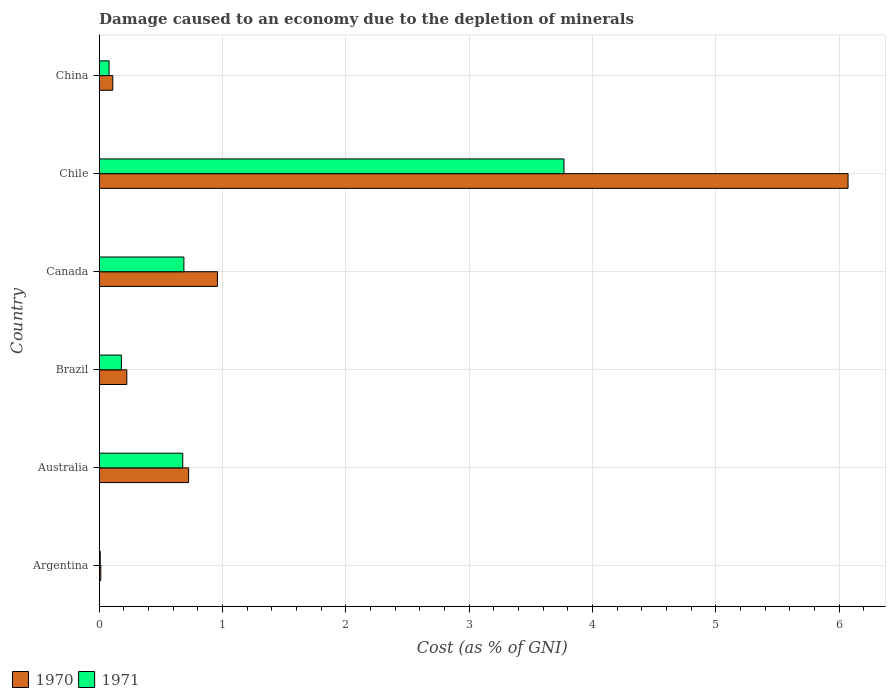How many groups of bars are there?
Provide a succinct answer. 6. Are the number of bars per tick equal to the number of legend labels?
Provide a succinct answer. Yes. Are the number of bars on each tick of the Y-axis equal?
Provide a short and direct response. Yes. What is the cost of damage caused due to the depletion of minerals in 1971 in Australia?
Your answer should be very brief. 0.68. Across all countries, what is the maximum cost of damage caused due to the depletion of minerals in 1971?
Give a very brief answer. 3.77. Across all countries, what is the minimum cost of damage caused due to the depletion of minerals in 1970?
Provide a short and direct response. 0.01. In which country was the cost of damage caused due to the depletion of minerals in 1971 maximum?
Give a very brief answer. Chile. What is the total cost of damage caused due to the depletion of minerals in 1971 in the graph?
Provide a short and direct response. 5.4. What is the difference between the cost of damage caused due to the depletion of minerals in 1971 in Australia and that in China?
Keep it short and to the point. 0.6. What is the difference between the cost of damage caused due to the depletion of minerals in 1970 in Argentina and the cost of damage caused due to the depletion of minerals in 1971 in Australia?
Provide a succinct answer. -0.66. What is the average cost of damage caused due to the depletion of minerals in 1971 per country?
Ensure brevity in your answer.  0.9. What is the difference between the cost of damage caused due to the depletion of minerals in 1971 and cost of damage caused due to the depletion of minerals in 1970 in Chile?
Provide a succinct answer. -2.3. What is the ratio of the cost of damage caused due to the depletion of minerals in 1971 in Australia to that in Brazil?
Ensure brevity in your answer.  3.77. Is the cost of damage caused due to the depletion of minerals in 1971 in Canada less than that in China?
Give a very brief answer. No. What is the difference between the highest and the second highest cost of damage caused due to the depletion of minerals in 1970?
Keep it short and to the point. 5.11. What is the difference between the highest and the lowest cost of damage caused due to the depletion of minerals in 1970?
Offer a very short reply. 6.06. In how many countries, is the cost of damage caused due to the depletion of minerals in 1970 greater than the average cost of damage caused due to the depletion of minerals in 1970 taken over all countries?
Your answer should be compact. 1. How many bars are there?
Make the answer very short. 12. What is the difference between two consecutive major ticks on the X-axis?
Ensure brevity in your answer.  1. Are the values on the major ticks of X-axis written in scientific E-notation?
Give a very brief answer. No. How many legend labels are there?
Ensure brevity in your answer.  2. What is the title of the graph?
Make the answer very short. Damage caused to an economy due to the depletion of minerals. What is the label or title of the X-axis?
Offer a terse response. Cost (as % of GNI). What is the Cost (as % of GNI) in 1970 in Argentina?
Provide a short and direct response. 0.01. What is the Cost (as % of GNI) in 1971 in Argentina?
Give a very brief answer. 0.01. What is the Cost (as % of GNI) in 1970 in Australia?
Provide a succinct answer. 0.72. What is the Cost (as % of GNI) in 1971 in Australia?
Make the answer very short. 0.68. What is the Cost (as % of GNI) of 1970 in Brazil?
Ensure brevity in your answer.  0.22. What is the Cost (as % of GNI) of 1971 in Brazil?
Your answer should be very brief. 0.18. What is the Cost (as % of GNI) in 1970 in Canada?
Provide a succinct answer. 0.96. What is the Cost (as % of GNI) in 1971 in Canada?
Provide a succinct answer. 0.69. What is the Cost (as % of GNI) in 1970 in Chile?
Your answer should be very brief. 6.07. What is the Cost (as % of GNI) of 1971 in Chile?
Your response must be concise. 3.77. What is the Cost (as % of GNI) in 1970 in China?
Give a very brief answer. 0.11. What is the Cost (as % of GNI) of 1971 in China?
Provide a succinct answer. 0.08. Across all countries, what is the maximum Cost (as % of GNI) of 1970?
Keep it short and to the point. 6.07. Across all countries, what is the maximum Cost (as % of GNI) in 1971?
Give a very brief answer. 3.77. Across all countries, what is the minimum Cost (as % of GNI) in 1970?
Offer a terse response. 0.01. Across all countries, what is the minimum Cost (as % of GNI) in 1971?
Your response must be concise. 0.01. What is the total Cost (as % of GNI) of 1970 in the graph?
Make the answer very short. 8.1. What is the difference between the Cost (as % of GNI) in 1970 in Argentina and that in Australia?
Give a very brief answer. -0.71. What is the difference between the Cost (as % of GNI) of 1971 in Argentina and that in Australia?
Your answer should be very brief. -0.67. What is the difference between the Cost (as % of GNI) of 1970 in Argentina and that in Brazil?
Provide a short and direct response. -0.21. What is the difference between the Cost (as % of GNI) in 1971 in Argentina and that in Brazil?
Provide a short and direct response. -0.17. What is the difference between the Cost (as % of GNI) in 1970 in Argentina and that in Canada?
Make the answer very short. -0.95. What is the difference between the Cost (as % of GNI) in 1971 in Argentina and that in Canada?
Offer a terse response. -0.68. What is the difference between the Cost (as % of GNI) of 1970 in Argentina and that in Chile?
Your answer should be very brief. -6.06. What is the difference between the Cost (as % of GNI) of 1971 in Argentina and that in Chile?
Ensure brevity in your answer.  -3.76. What is the difference between the Cost (as % of GNI) in 1970 in Argentina and that in China?
Your answer should be compact. -0.1. What is the difference between the Cost (as % of GNI) of 1971 in Argentina and that in China?
Your response must be concise. -0.07. What is the difference between the Cost (as % of GNI) of 1970 in Australia and that in Brazil?
Provide a succinct answer. 0.5. What is the difference between the Cost (as % of GNI) in 1971 in Australia and that in Brazil?
Your answer should be very brief. 0.5. What is the difference between the Cost (as % of GNI) of 1970 in Australia and that in Canada?
Ensure brevity in your answer.  -0.23. What is the difference between the Cost (as % of GNI) of 1971 in Australia and that in Canada?
Your response must be concise. -0.01. What is the difference between the Cost (as % of GNI) in 1970 in Australia and that in Chile?
Keep it short and to the point. -5.35. What is the difference between the Cost (as % of GNI) in 1971 in Australia and that in Chile?
Your answer should be compact. -3.09. What is the difference between the Cost (as % of GNI) in 1970 in Australia and that in China?
Keep it short and to the point. 0.61. What is the difference between the Cost (as % of GNI) of 1971 in Australia and that in China?
Provide a short and direct response. 0.6. What is the difference between the Cost (as % of GNI) of 1970 in Brazil and that in Canada?
Keep it short and to the point. -0.73. What is the difference between the Cost (as % of GNI) of 1971 in Brazil and that in Canada?
Your answer should be compact. -0.51. What is the difference between the Cost (as % of GNI) in 1970 in Brazil and that in Chile?
Provide a succinct answer. -5.85. What is the difference between the Cost (as % of GNI) in 1971 in Brazil and that in Chile?
Provide a succinct answer. -3.59. What is the difference between the Cost (as % of GNI) in 1970 in Brazil and that in China?
Ensure brevity in your answer.  0.11. What is the difference between the Cost (as % of GNI) in 1971 in Brazil and that in China?
Provide a succinct answer. 0.1. What is the difference between the Cost (as % of GNI) of 1970 in Canada and that in Chile?
Keep it short and to the point. -5.11. What is the difference between the Cost (as % of GNI) of 1971 in Canada and that in Chile?
Your answer should be compact. -3.08. What is the difference between the Cost (as % of GNI) in 1970 in Canada and that in China?
Your answer should be very brief. 0.85. What is the difference between the Cost (as % of GNI) in 1971 in Canada and that in China?
Give a very brief answer. 0.61. What is the difference between the Cost (as % of GNI) of 1970 in Chile and that in China?
Provide a short and direct response. 5.96. What is the difference between the Cost (as % of GNI) of 1971 in Chile and that in China?
Make the answer very short. 3.69. What is the difference between the Cost (as % of GNI) of 1970 in Argentina and the Cost (as % of GNI) of 1971 in Australia?
Offer a terse response. -0.66. What is the difference between the Cost (as % of GNI) of 1970 in Argentina and the Cost (as % of GNI) of 1971 in Brazil?
Your answer should be compact. -0.17. What is the difference between the Cost (as % of GNI) of 1970 in Argentina and the Cost (as % of GNI) of 1971 in Canada?
Provide a succinct answer. -0.67. What is the difference between the Cost (as % of GNI) in 1970 in Argentina and the Cost (as % of GNI) in 1971 in Chile?
Provide a short and direct response. -3.76. What is the difference between the Cost (as % of GNI) in 1970 in Argentina and the Cost (as % of GNI) in 1971 in China?
Offer a very short reply. -0.07. What is the difference between the Cost (as % of GNI) in 1970 in Australia and the Cost (as % of GNI) in 1971 in Brazil?
Your answer should be very brief. 0.55. What is the difference between the Cost (as % of GNI) in 1970 in Australia and the Cost (as % of GNI) in 1971 in Canada?
Make the answer very short. 0.04. What is the difference between the Cost (as % of GNI) of 1970 in Australia and the Cost (as % of GNI) of 1971 in Chile?
Your answer should be very brief. -3.04. What is the difference between the Cost (as % of GNI) in 1970 in Australia and the Cost (as % of GNI) in 1971 in China?
Ensure brevity in your answer.  0.65. What is the difference between the Cost (as % of GNI) of 1970 in Brazil and the Cost (as % of GNI) of 1971 in Canada?
Your response must be concise. -0.46. What is the difference between the Cost (as % of GNI) of 1970 in Brazil and the Cost (as % of GNI) of 1971 in Chile?
Give a very brief answer. -3.54. What is the difference between the Cost (as % of GNI) of 1970 in Brazil and the Cost (as % of GNI) of 1971 in China?
Give a very brief answer. 0.14. What is the difference between the Cost (as % of GNI) in 1970 in Canada and the Cost (as % of GNI) in 1971 in Chile?
Provide a short and direct response. -2.81. What is the difference between the Cost (as % of GNI) in 1970 in Canada and the Cost (as % of GNI) in 1971 in China?
Keep it short and to the point. 0.88. What is the difference between the Cost (as % of GNI) in 1970 in Chile and the Cost (as % of GNI) in 1971 in China?
Make the answer very short. 5.99. What is the average Cost (as % of GNI) of 1970 per country?
Offer a very short reply. 1.35. What is the difference between the Cost (as % of GNI) in 1970 and Cost (as % of GNI) in 1971 in Argentina?
Provide a succinct answer. 0. What is the difference between the Cost (as % of GNI) in 1970 and Cost (as % of GNI) in 1971 in Australia?
Ensure brevity in your answer.  0.05. What is the difference between the Cost (as % of GNI) in 1970 and Cost (as % of GNI) in 1971 in Brazil?
Provide a succinct answer. 0.04. What is the difference between the Cost (as % of GNI) in 1970 and Cost (as % of GNI) in 1971 in Canada?
Provide a succinct answer. 0.27. What is the difference between the Cost (as % of GNI) of 1970 and Cost (as % of GNI) of 1971 in Chile?
Provide a short and direct response. 2.3. What is the difference between the Cost (as % of GNI) of 1970 and Cost (as % of GNI) of 1971 in China?
Offer a terse response. 0.03. What is the ratio of the Cost (as % of GNI) of 1970 in Argentina to that in Australia?
Keep it short and to the point. 0.02. What is the ratio of the Cost (as % of GNI) in 1971 in Argentina to that in Australia?
Give a very brief answer. 0.01. What is the ratio of the Cost (as % of GNI) in 1970 in Argentina to that in Brazil?
Make the answer very short. 0.06. What is the ratio of the Cost (as % of GNI) of 1971 in Argentina to that in Brazil?
Keep it short and to the point. 0.05. What is the ratio of the Cost (as % of GNI) of 1970 in Argentina to that in Canada?
Ensure brevity in your answer.  0.01. What is the ratio of the Cost (as % of GNI) of 1971 in Argentina to that in Canada?
Keep it short and to the point. 0.01. What is the ratio of the Cost (as % of GNI) of 1970 in Argentina to that in Chile?
Your answer should be compact. 0. What is the ratio of the Cost (as % of GNI) of 1971 in Argentina to that in Chile?
Keep it short and to the point. 0. What is the ratio of the Cost (as % of GNI) of 1970 in Argentina to that in China?
Your answer should be very brief. 0.11. What is the ratio of the Cost (as % of GNI) of 1971 in Argentina to that in China?
Provide a succinct answer. 0.1. What is the ratio of the Cost (as % of GNI) of 1970 in Australia to that in Brazil?
Give a very brief answer. 3.24. What is the ratio of the Cost (as % of GNI) of 1971 in Australia to that in Brazil?
Offer a very short reply. 3.77. What is the ratio of the Cost (as % of GNI) of 1970 in Australia to that in Canada?
Provide a short and direct response. 0.76. What is the ratio of the Cost (as % of GNI) of 1971 in Australia to that in Canada?
Provide a short and direct response. 0.99. What is the ratio of the Cost (as % of GNI) of 1970 in Australia to that in Chile?
Ensure brevity in your answer.  0.12. What is the ratio of the Cost (as % of GNI) in 1971 in Australia to that in Chile?
Give a very brief answer. 0.18. What is the ratio of the Cost (as % of GNI) of 1970 in Australia to that in China?
Make the answer very short. 6.59. What is the ratio of the Cost (as % of GNI) of 1971 in Australia to that in China?
Your response must be concise. 8.49. What is the ratio of the Cost (as % of GNI) of 1970 in Brazil to that in Canada?
Offer a terse response. 0.23. What is the ratio of the Cost (as % of GNI) of 1971 in Brazil to that in Canada?
Keep it short and to the point. 0.26. What is the ratio of the Cost (as % of GNI) in 1970 in Brazil to that in Chile?
Your answer should be compact. 0.04. What is the ratio of the Cost (as % of GNI) of 1971 in Brazil to that in Chile?
Keep it short and to the point. 0.05. What is the ratio of the Cost (as % of GNI) of 1970 in Brazil to that in China?
Provide a short and direct response. 2.03. What is the ratio of the Cost (as % of GNI) of 1971 in Brazil to that in China?
Ensure brevity in your answer.  2.25. What is the ratio of the Cost (as % of GNI) of 1970 in Canada to that in Chile?
Your response must be concise. 0.16. What is the ratio of the Cost (as % of GNI) of 1971 in Canada to that in Chile?
Make the answer very short. 0.18. What is the ratio of the Cost (as % of GNI) of 1970 in Canada to that in China?
Keep it short and to the point. 8.72. What is the ratio of the Cost (as % of GNI) of 1971 in Canada to that in China?
Provide a short and direct response. 8.61. What is the ratio of the Cost (as % of GNI) in 1970 in Chile to that in China?
Offer a terse response. 55.21. What is the ratio of the Cost (as % of GNI) in 1971 in Chile to that in China?
Offer a very short reply. 47.22. What is the difference between the highest and the second highest Cost (as % of GNI) of 1970?
Offer a very short reply. 5.11. What is the difference between the highest and the second highest Cost (as % of GNI) in 1971?
Provide a short and direct response. 3.08. What is the difference between the highest and the lowest Cost (as % of GNI) of 1970?
Keep it short and to the point. 6.06. What is the difference between the highest and the lowest Cost (as % of GNI) of 1971?
Offer a terse response. 3.76. 